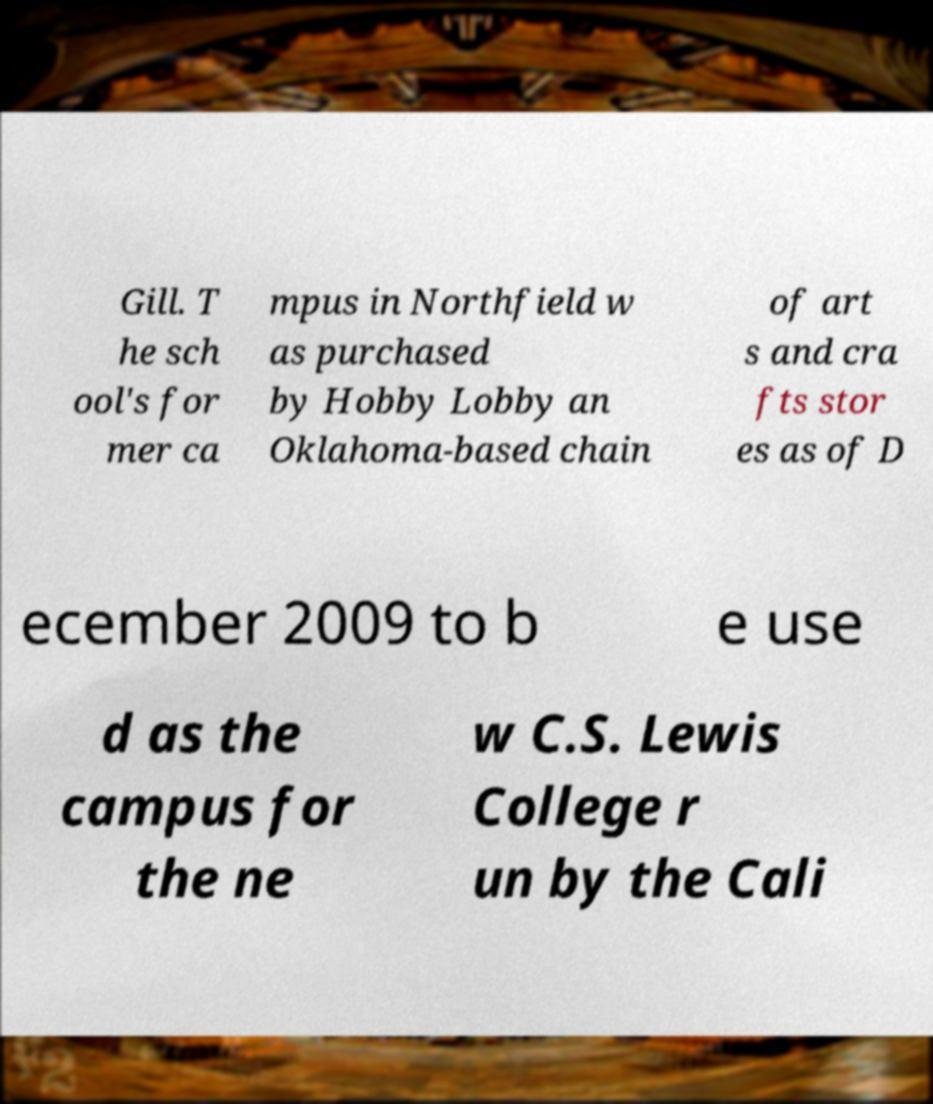I need the written content from this picture converted into text. Can you do that? Gill. T he sch ool's for mer ca mpus in Northfield w as purchased by Hobby Lobby an Oklahoma-based chain of art s and cra fts stor es as of D ecember 2009 to b e use d as the campus for the ne w C.S. Lewis College r un by the Cali 